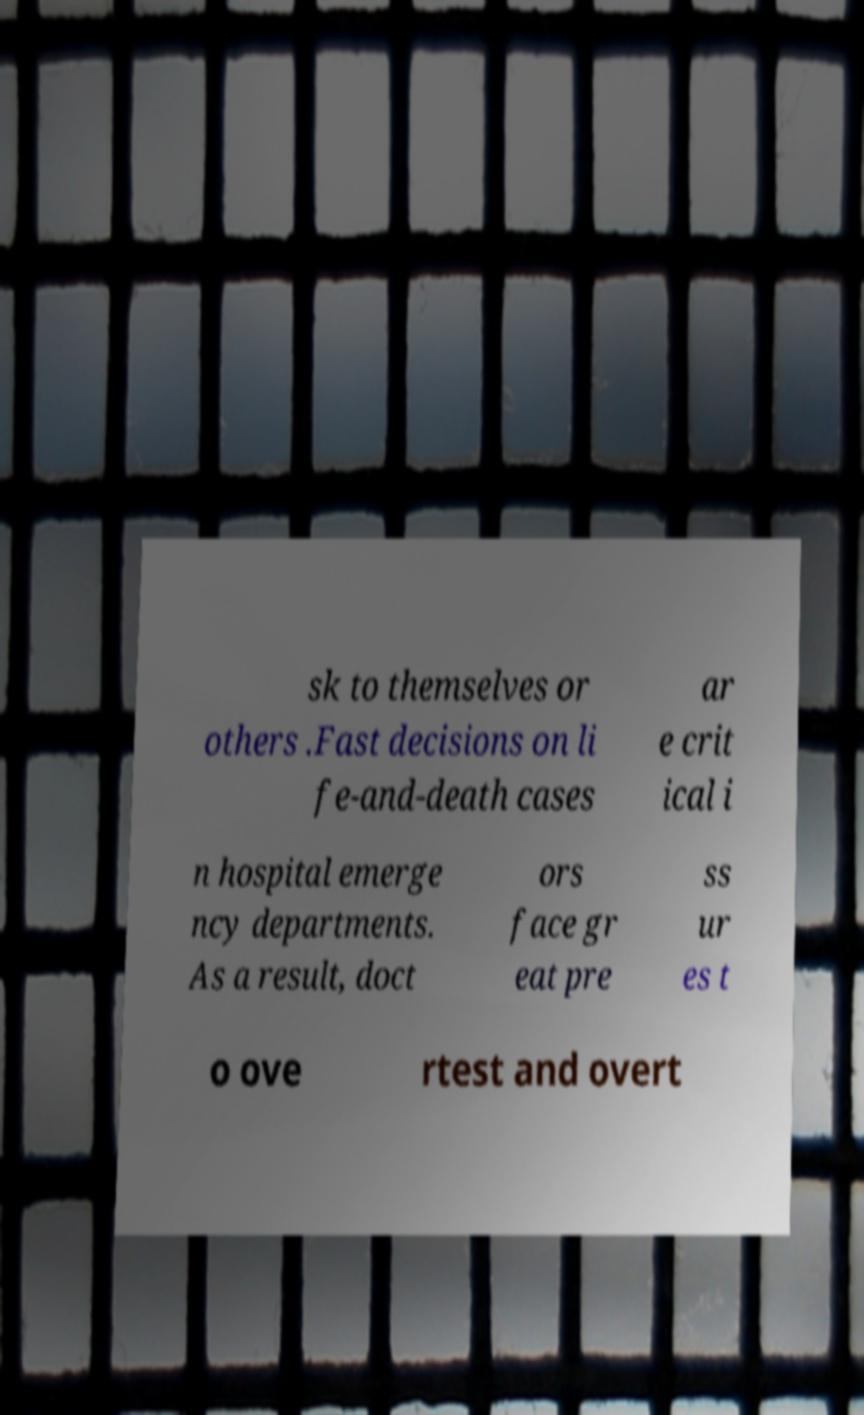Please read and relay the text visible in this image. What does it say? sk to themselves or others .Fast decisions on li fe-and-death cases ar e crit ical i n hospital emerge ncy departments. As a result, doct ors face gr eat pre ss ur es t o ove rtest and overt 